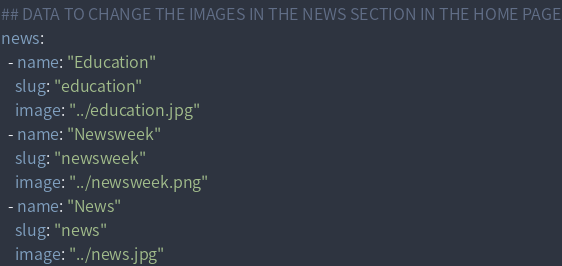Convert code to text. <code><loc_0><loc_0><loc_500><loc_500><_YAML_>## DATA TO CHANGE THE IMAGES IN THE NEWS SECTION IN THE HOME PAGE
news:
  - name: "Education"
    slug: "education"
    image: "../education.jpg"
  - name: "Newsweek"
    slug: "newsweek"
    image: "../newsweek.png"
  - name: "News"
    slug: "news"
    image: "../news.jpg"
</code> 